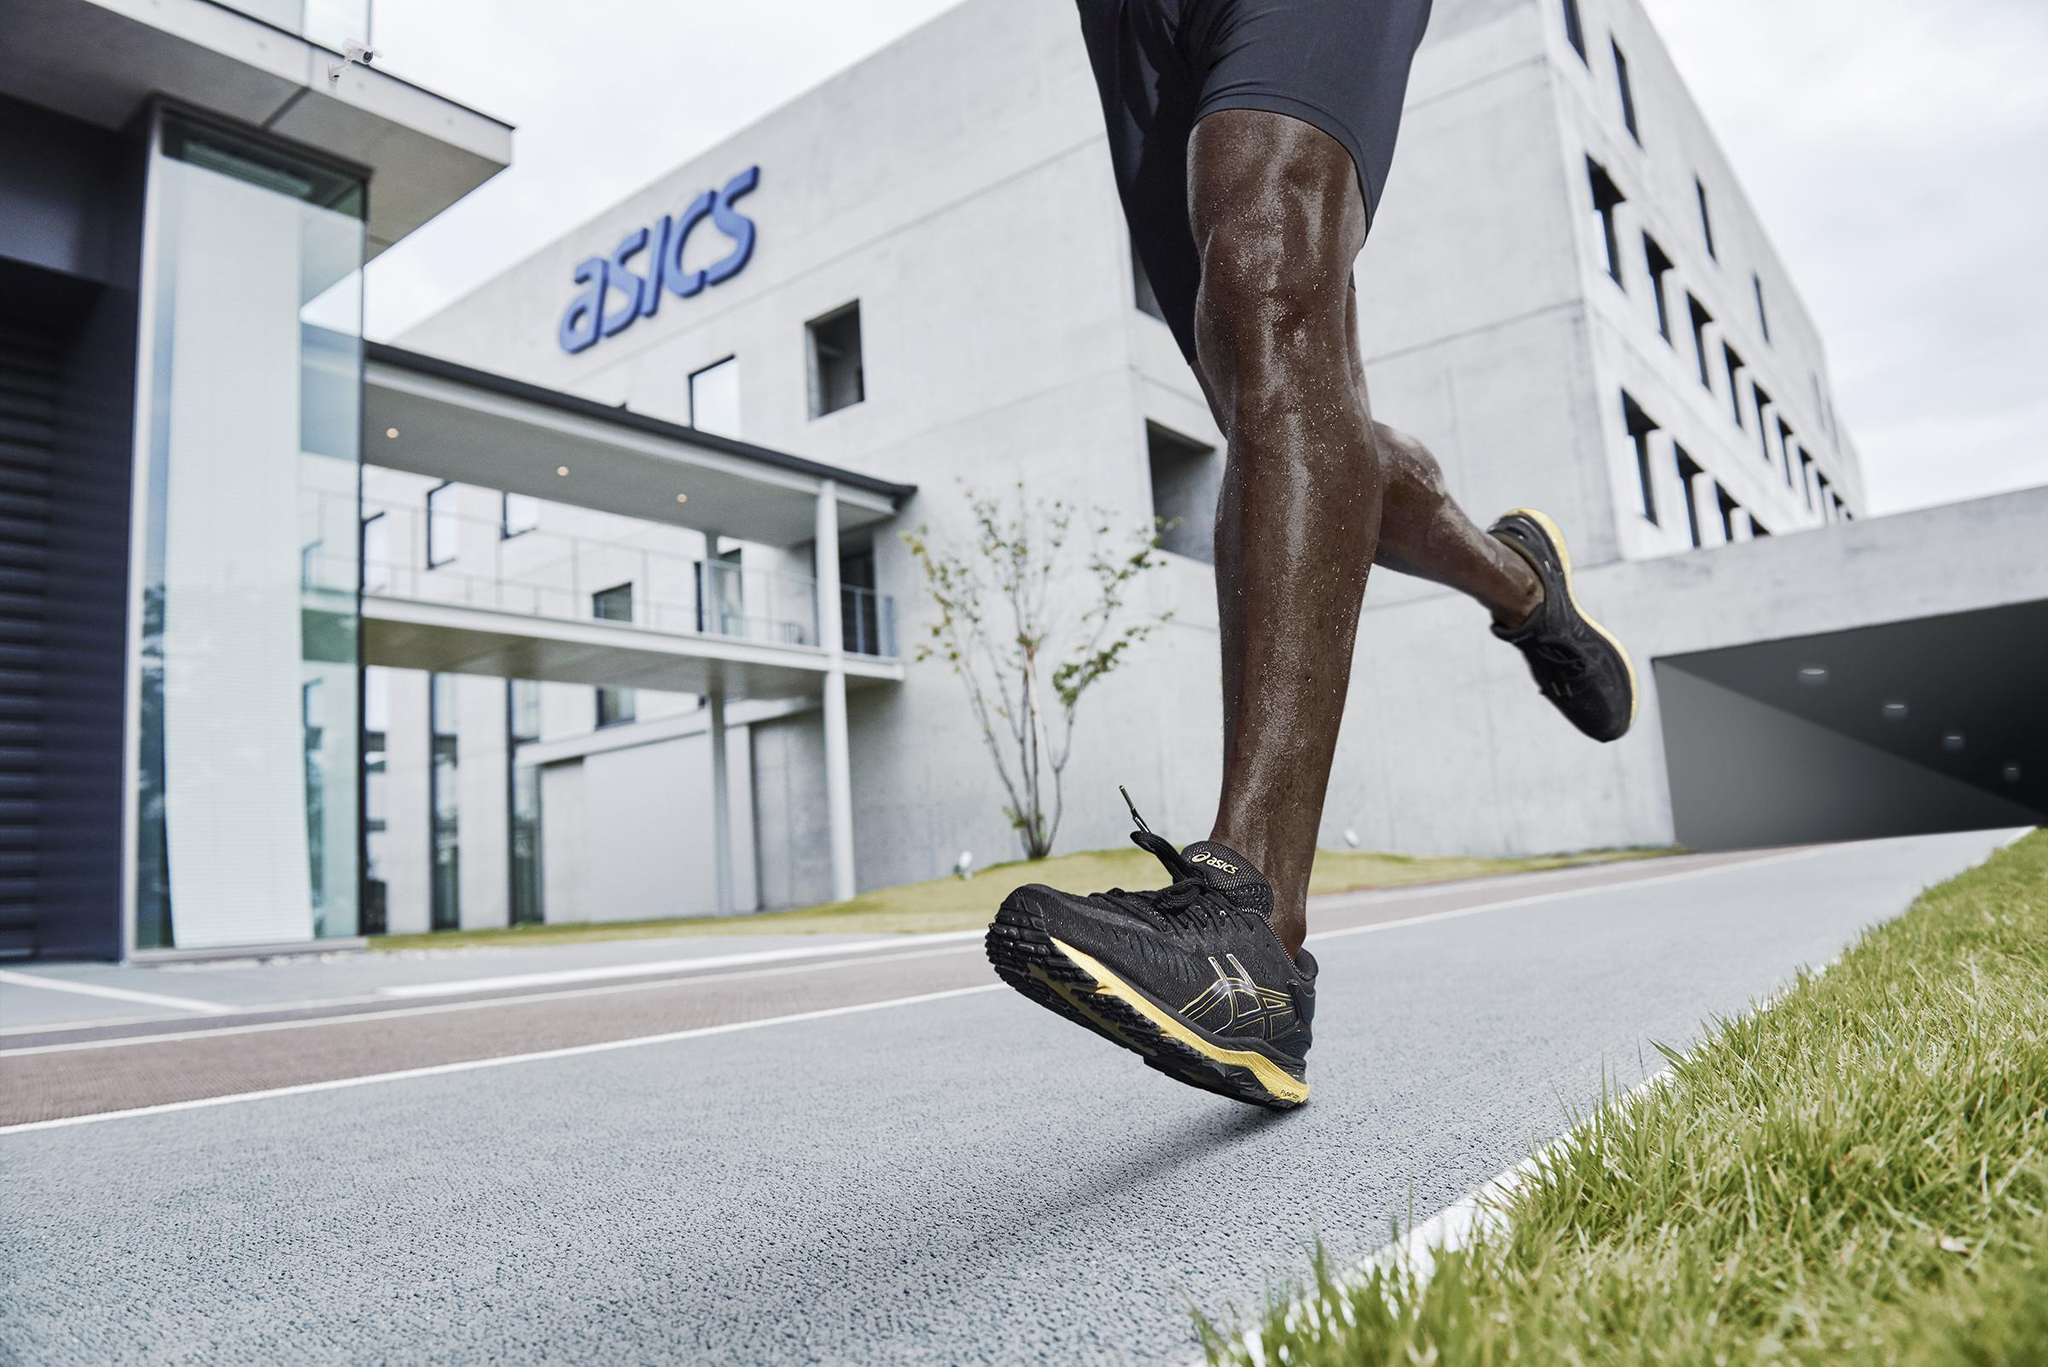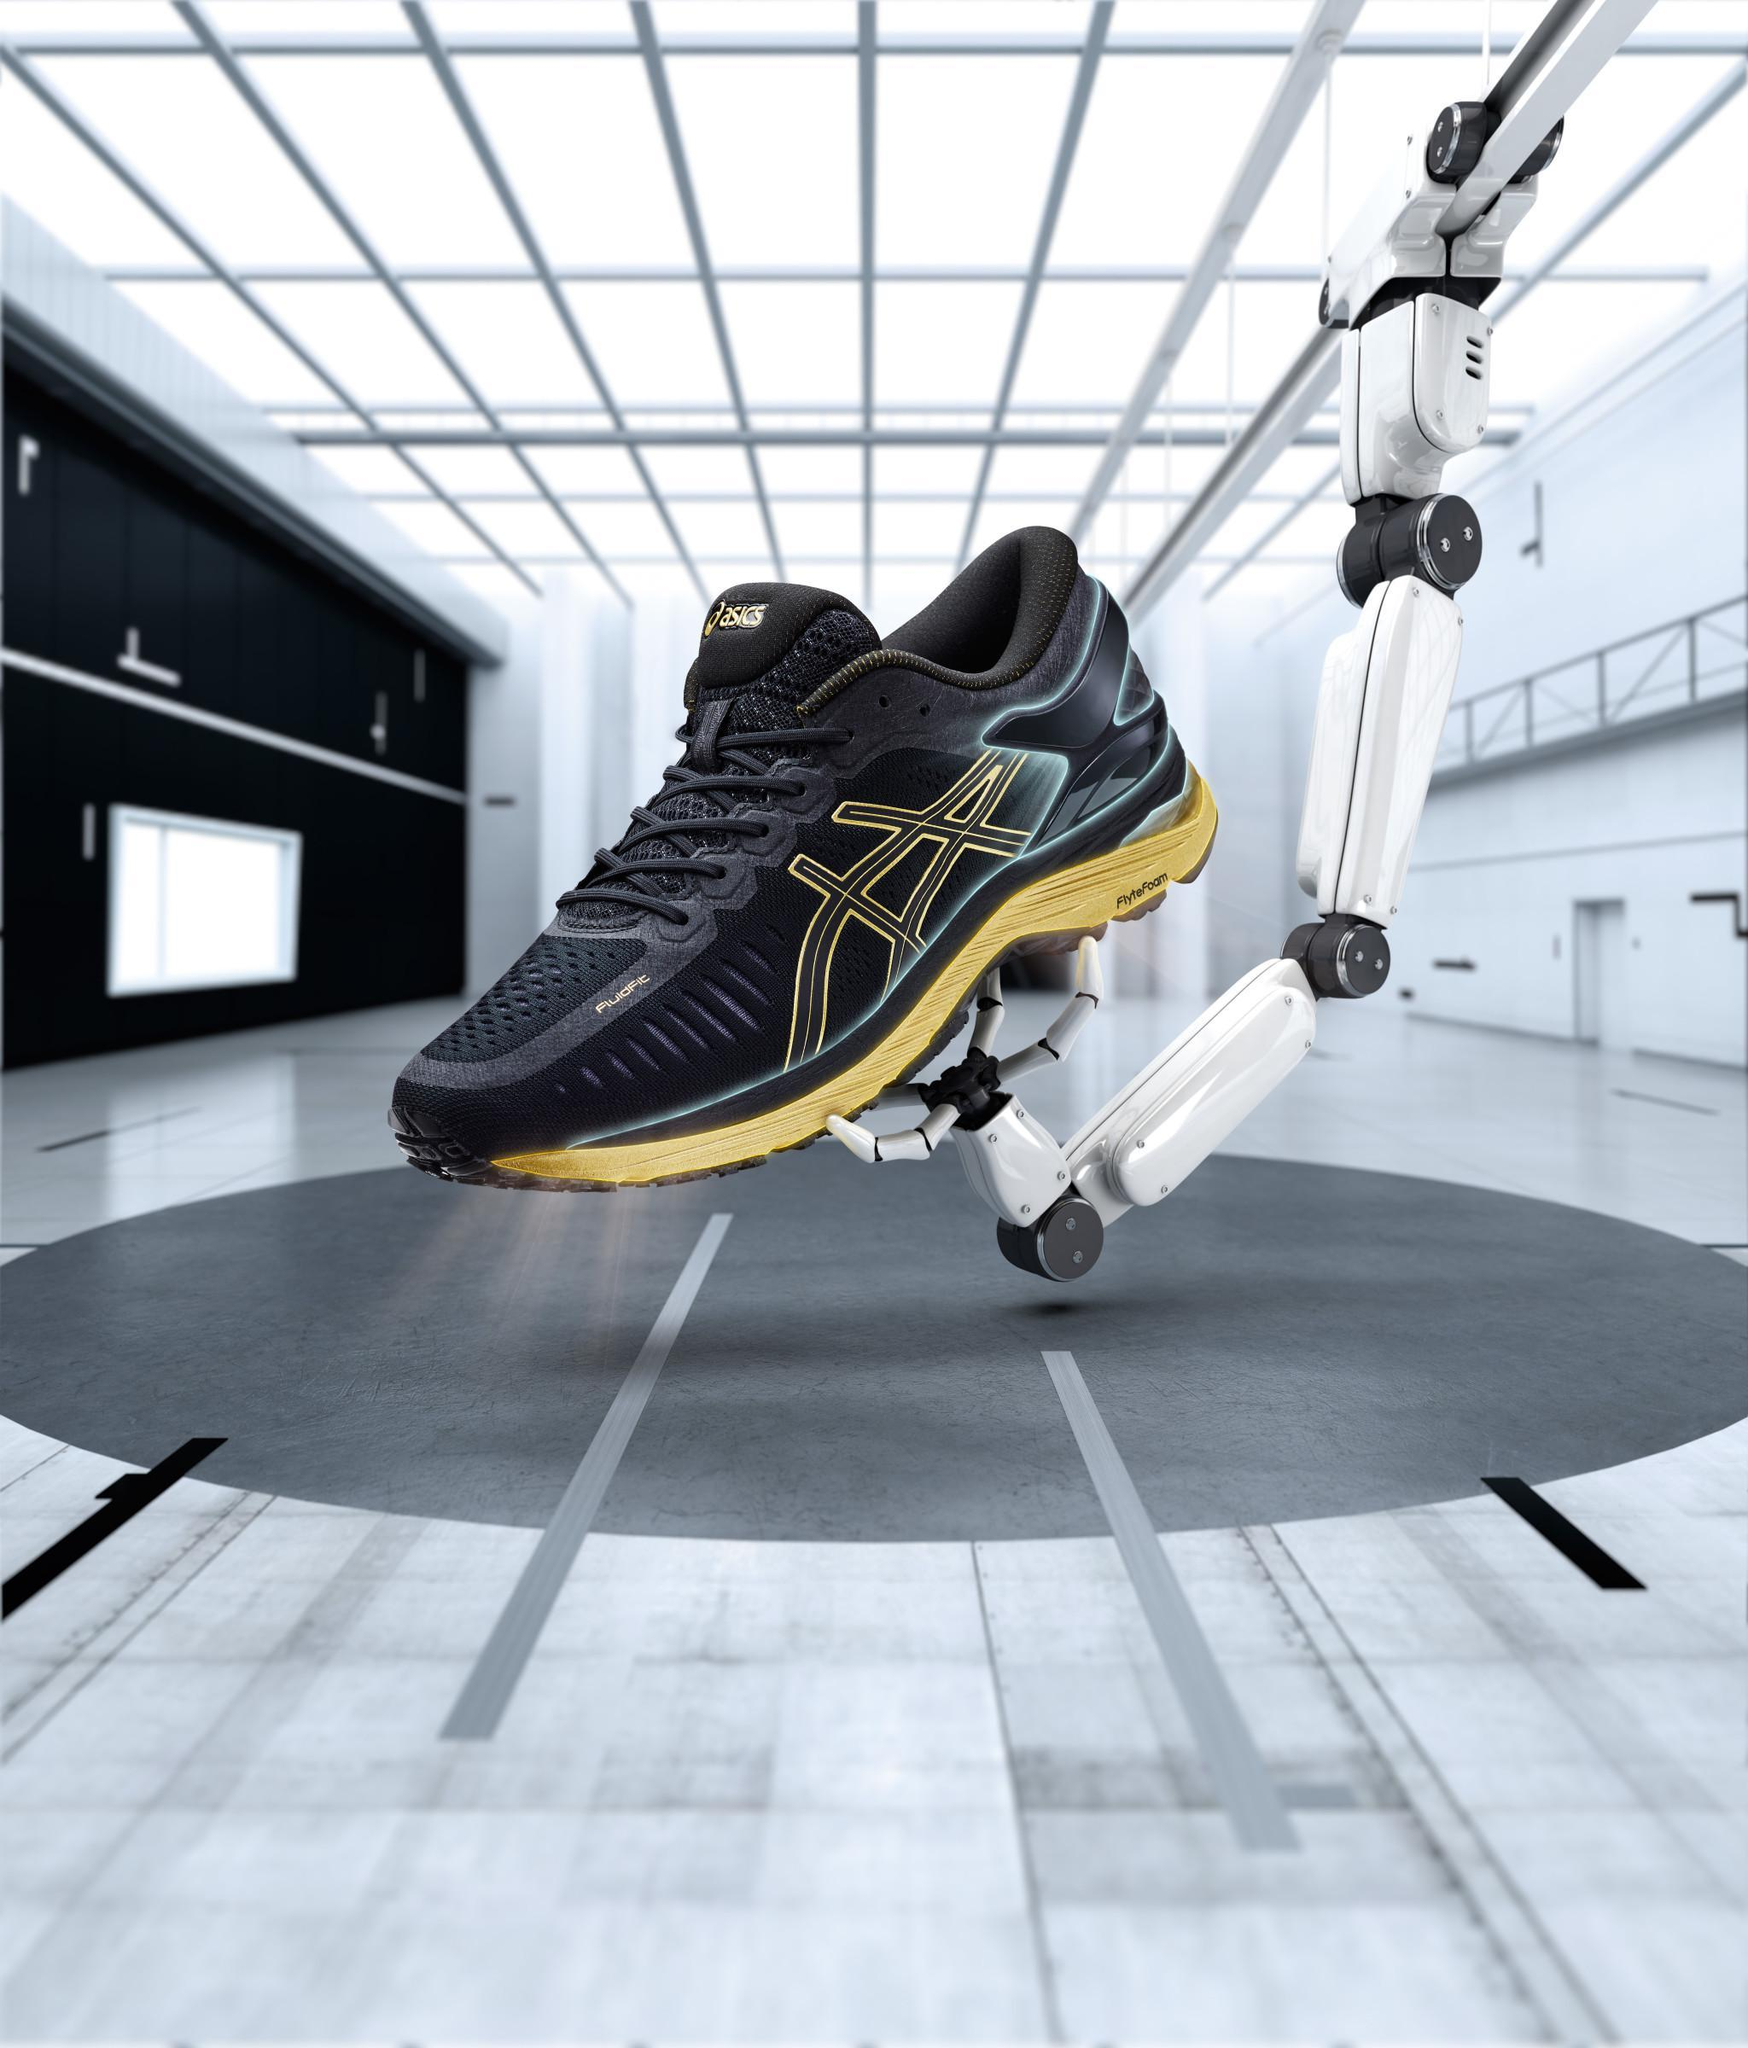The first image is the image on the left, the second image is the image on the right. Evaluate the accuracy of this statement regarding the images: "There is a running shoe presented by a robotic arm in at least one of the images.". Is it true? Answer yes or no. Yes. 